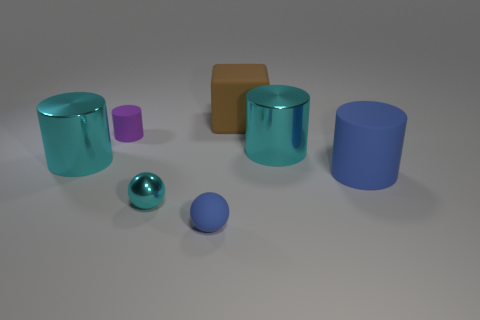Subtract all small matte cylinders. How many cylinders are left? 3 Subtract all cyan balls. How many cyan cylinders are left? 2 Subtract all cyan cylinders. How many cylinders are left? 2 Subtract 2 cylinders. How many cylinders are left? 2 Add 1 small rubber cylinders. How many objects exist? 8 Subtract all blocks. How many objects are left? 6 Subtract all small gray cylinders. Subtract all purple rubber cylinders. How many objects are left? 6 Add 1 small cylinders. How many small cylinders are left? 2 Add 3 large matte blocks. How many large matte blocks exist? 4 Subtract 1 blue cylinders. How many objects are left? 6 